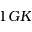Convert formula to latex. <formula><loc_0><loc_0><loc_500><loc_500>1 G K</formula> 